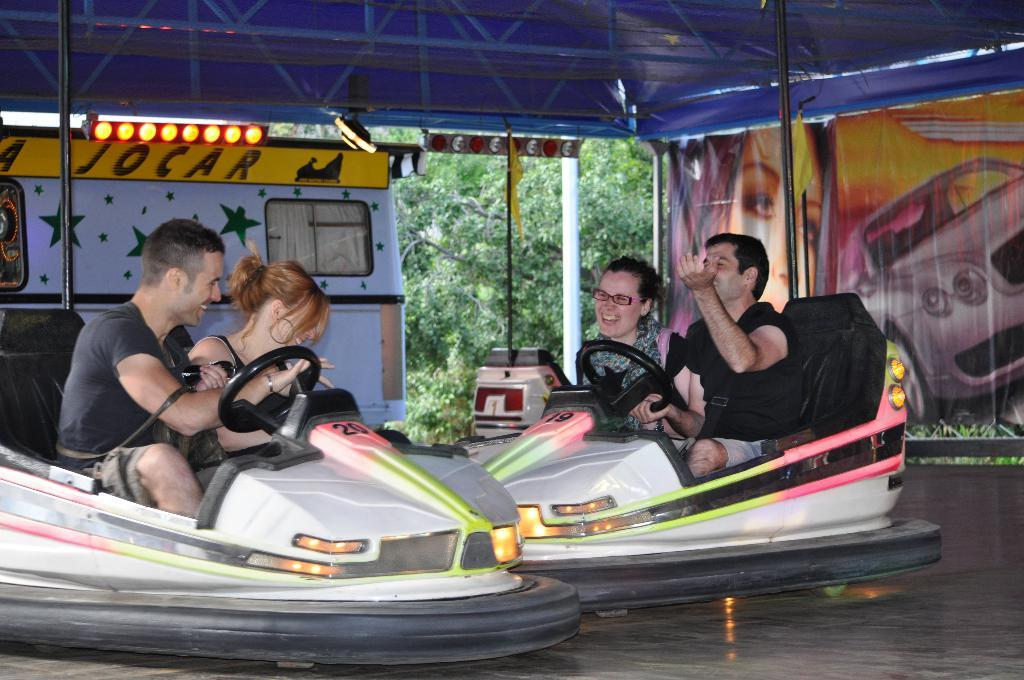What are the people in the image doing? The people in the image are sitting in vehicles. What structures can be seen in the image? There are poles, boards, a banner, lights, and a shed in the image. What is the background of the image? Leaves are visible in the background of the image. Is there a baseball game taking place in the image? There is no indication of a baseball game in the image. What time of day is it in the image? The time of day cannot be determined from the image alone, as there are no specific clues about the lighting or shadows. 